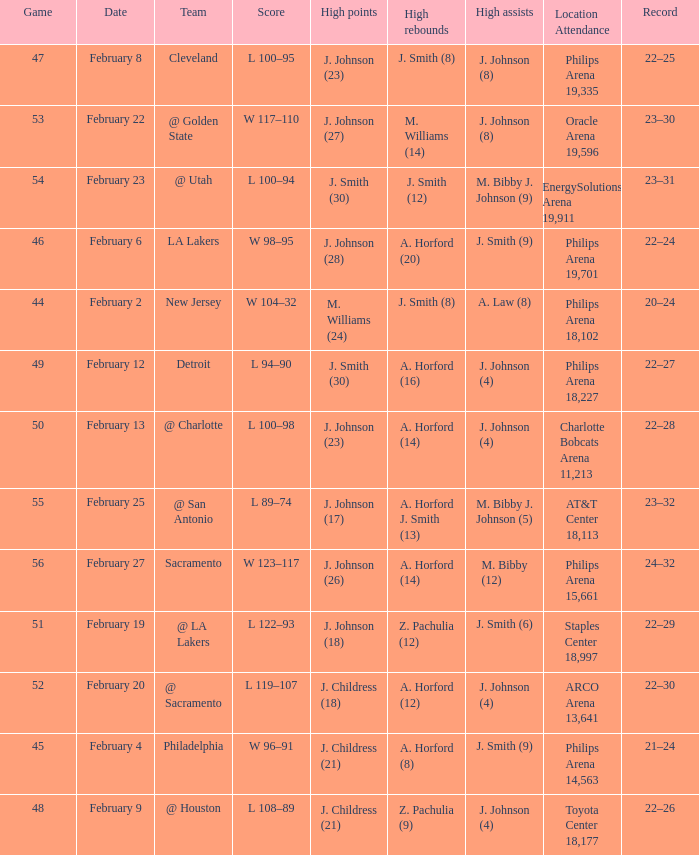What is the team located at philips arena 18,227? Detroit. 